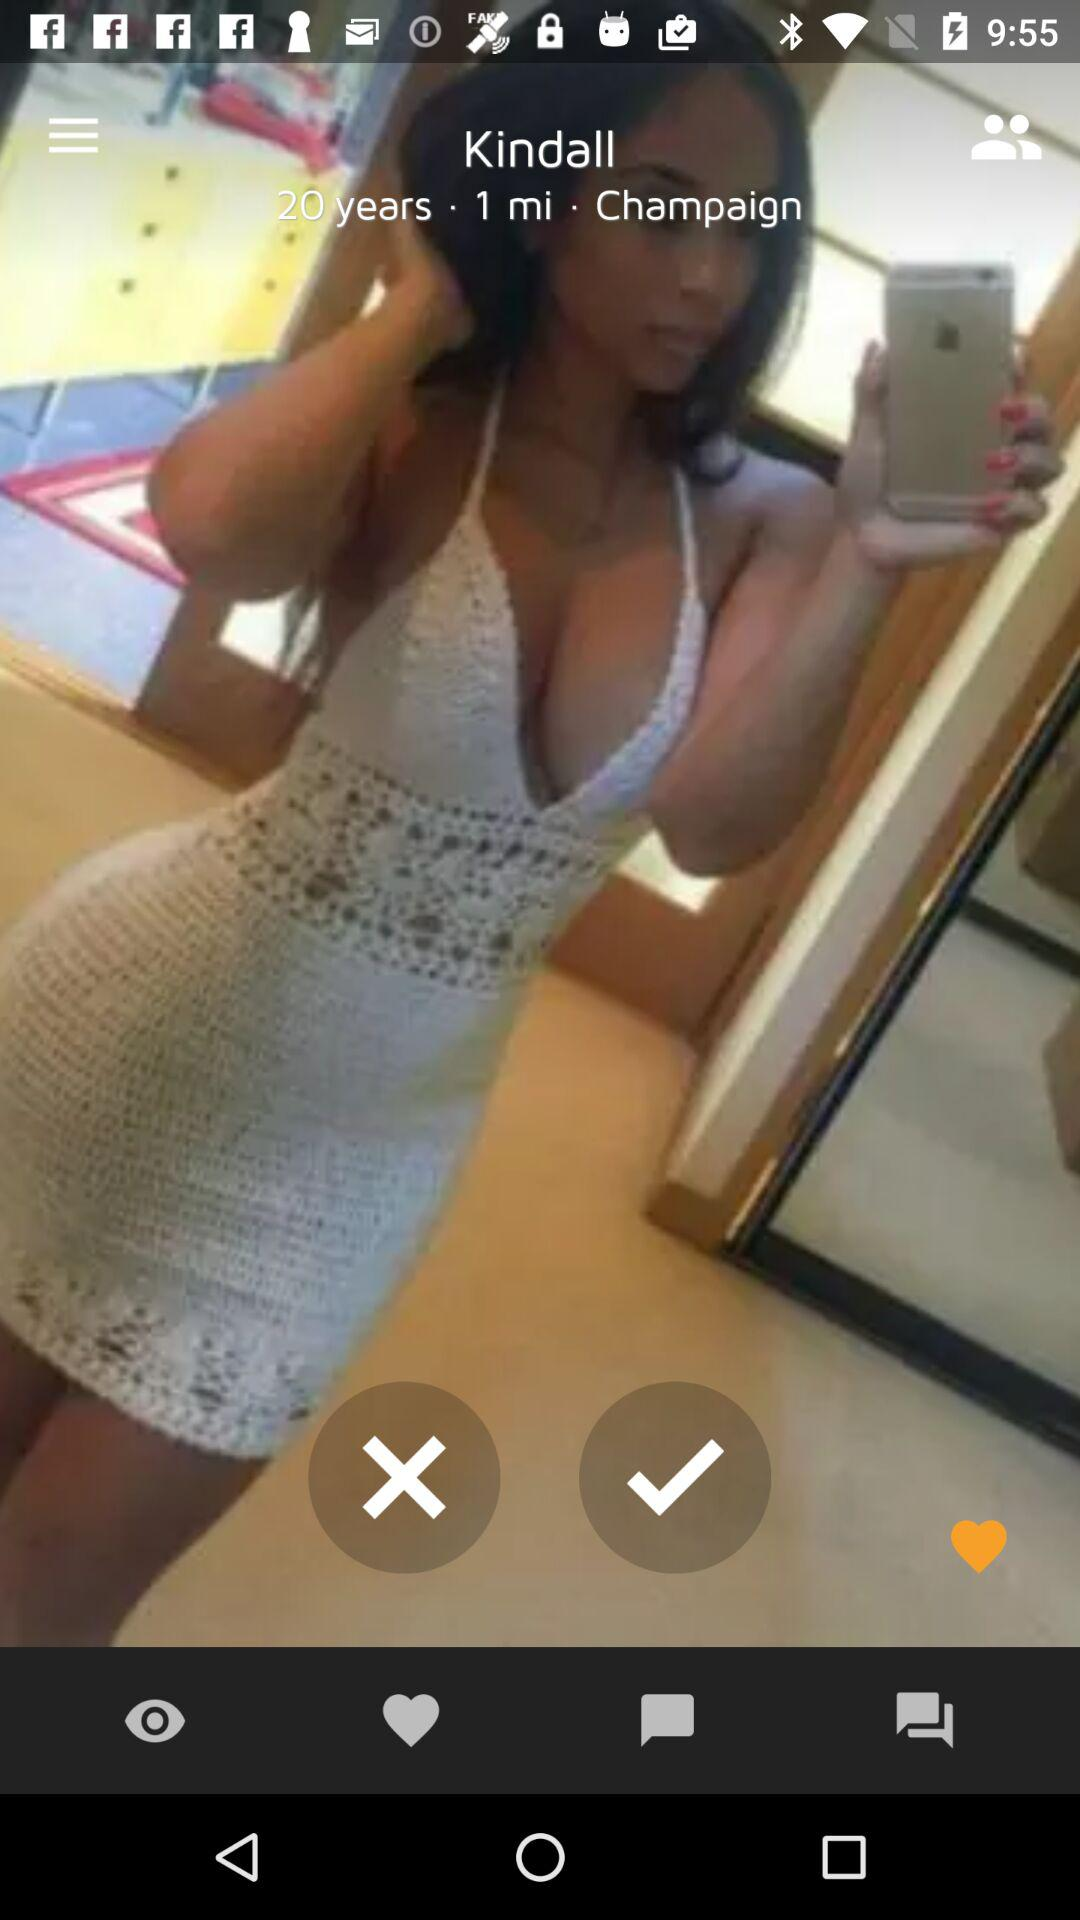What is Kindall's age? Kindall is 20 years old. 